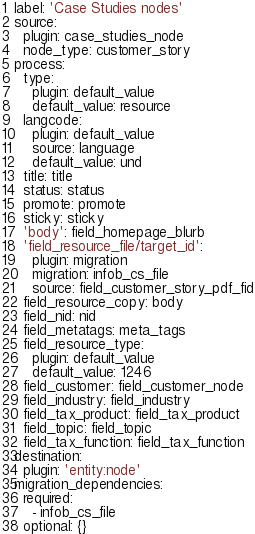<code> <loc_0><loc_0><loc_500><loc_500><_YAML_>label: 'Case Studies nodes'
source:
  plugin: case_studies_node
  node_type: customer_story
process:
  type:
    plugin: default_value
    default_value: resource
  langcode:
    plugin: default_value
    source: language
    default_value: und
  title: title
  status: status
  promote: promote
  sticky: sticky
  'body': field_homepage_blurb
  'field_resource_file/target_id':
    plugin: migration
    migration: infob_cs_file
    source: field_customer_story_pdf_fid
  field_resource_copy: body
  field_nid: nid
  field_metatags: meta_tags
  field_resource_type:
    plugin: default_value
    default_value: 1246
  field_customer: field_customer_node
  field_industry: field_industry
  field_tax_product: field_tax_product
  field_topic: field_topic
  field_tax_function: field_tax_function
destination:
  plugin: 'entity:node'
migration_dependencies:
  required:
    - infob_cs_file
  optional: {}
</code> 